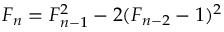<formula> <loc_0><loc_0><loc_500><loc_500>F _ { n } = F _ { n - 1 } ^ { 2 } - 2 ( F _ { n - 2 } - 1 ) ^ { 2 }</formula> 